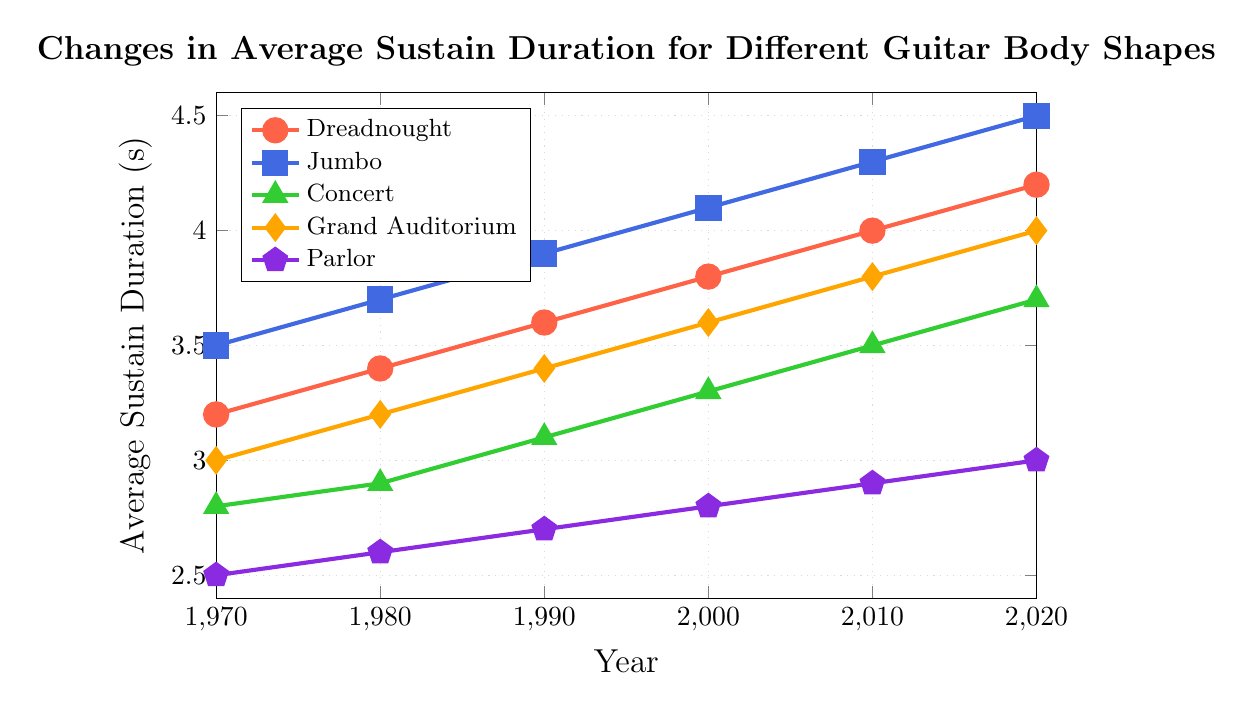What's the overall trend for the sustain duration of the Dreadnought guitar body shape from 1970 to 2020? The sustain duration for the Dreadnought guitar body shape gradually increases from 3.2 seconds in 1970 to 4.2 seconds in 2020, indicating a steady rise over the 50-year span.
Answer: Steady increase Which guitar body shape had the highest average sustain duration in 2020? In 2020, the Jumbo guitar body shape had the highest average sustain duration of 4.5 seconds.
Answer: Jumbo Compare the average sustain duration of the Parlor and Concert body shapes in 2000. Which one had a higher value and by how much? In 2000, the average sustain duration for the Parlor body shape was 2.8 seconds, and for the Concert body shape, it was 3.3 seconds. The Concert shape had a higher value by 0.5 seconds.
Answer: Concert by 0.5 seconds What is the difference between the average sustain duration of the Grand Auditorium and the Dreadnought body shapes in 2010? In 2010, the average sustain duration for the Grand Auditorium was 3.8 seconds, and for the Dreadnought, it was 4.0 seconds. The difference between them is 0.2 seconds.
Answer: 0.2 seconds Calculate the average sustain duration for all guitar body shapes in 1990. The sustain durations for 1990 are: Dreadnought (3.6), Jumbo (3.9), Concert (3.1), Grand Auditorium (3.4), and Parlor (2.7). Adding these gives 16.7, and the average is 16.7/5 = 3.34 seconds.
Answer: 3.34 seconds Between which consecutive decades was the largest increase in the average sustain duration for the Jumbo guitar body shape observed? The increases for the Jumbo body shape are: 1970-1980 (0.2), 1980-1990 (0.2), 1990-2000 (0.2), 2000-2010 (0.2), 2010-2020 (0.2). All increases are equal at 0.2 seconds.
Answer: All increases are equal What color represents the Grand Auditorium body shape in the chart? The Grand Auditorium body shape is represented by the orange line in the chart.
Answer: Orange How much did the average sustain duration for the Concert body shape change from 1980 to 2000? The sustain duration for the Concert body shape increased from 2.9 seconds in 1980 to 3.3 seconds in 2000. The change is 3.3 - 2.9 = 0.4 seconds.
Answer: 0.4 seconds Which body shape showed the least increase in sustain duration from 1970 to 2020, and what was the total increase? The Parlor body shape showed the least increase in sustain duration, with an increase from 2.5 seconds in 1970 to 3.0 seconds in 2020, totaling 0.5 seconds.
Answer: Parlor, 0.5 seconds What is the combined sustain duration of all guitar body shapes in the year 2020? The sustain durations for 2020 are: Dreadnought (4.2), Jumbo (4.5), Concert (3.7), Grand Auditorium (4.0), and Parlor (3.0), summing up to 19.4 seconds.
Answer: 19.4 seconds 